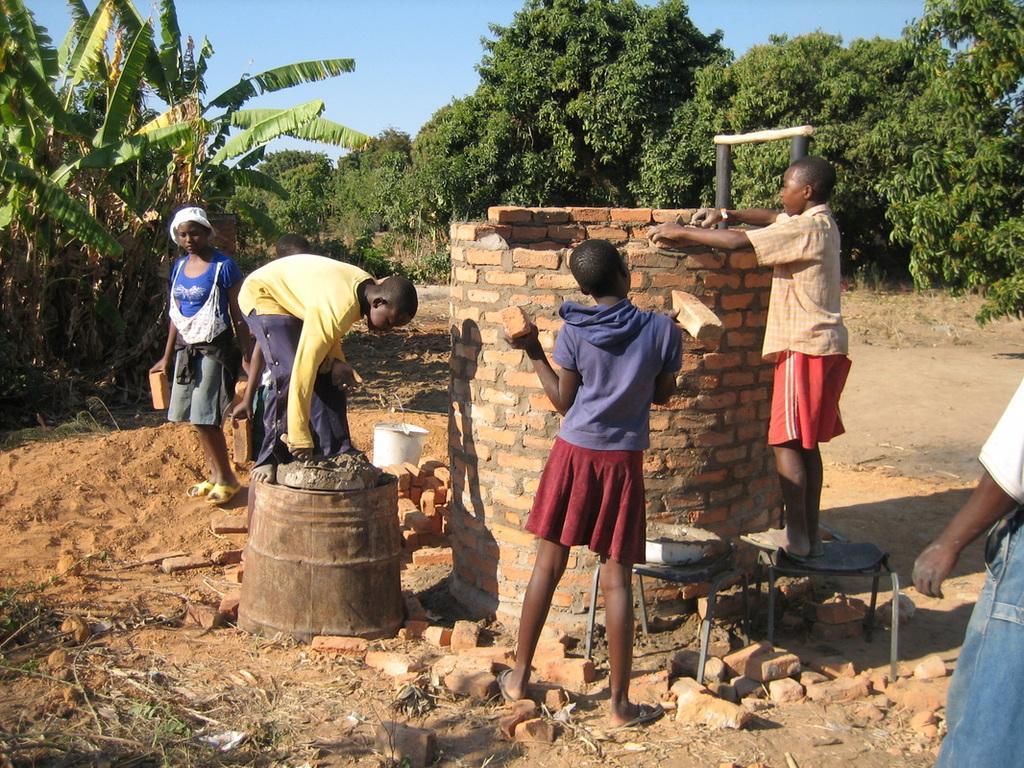How would you summarize this image in a sentence or two? In this picture we can see a group of people. On the ground there are stools, a bucket, bricks, sand and it looks like an iron barrel. A person is constructing a structure. Behind the people there are trees and the sky. 